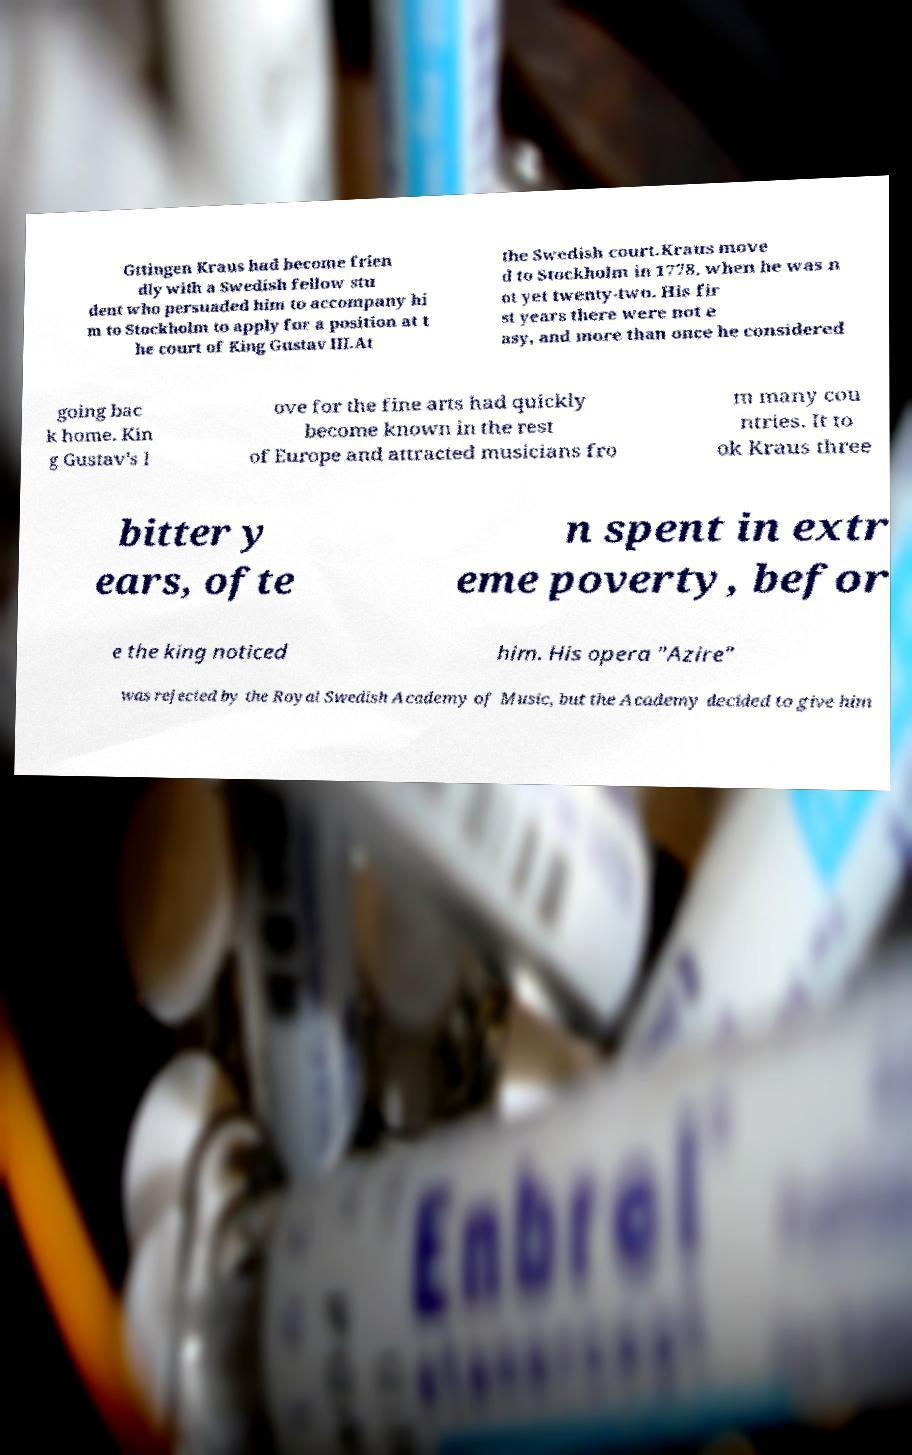There's text embedded in this image that I need extracted. Can you transcribe it verbatim? Gttingen Kraus had become frien dly with a Swedish fellow stu dent who persuaded him to accompany hi m to Stockholm to apply for a position at t he court of King Gustav III.At the Swedish court.Kraus move d to Stockholm in 1778, when he was n ot yet twenty-two. His fir st years there were not e asy, and more than once he considered going bac k home. Kin g Gustav's l ove for the fine arts had quickly become known in the rest of Europe and attracted musicians fro m many cou ntries. It to ok Kraus three bitter y ears, ofte n spent in extr eme poverty, befor e the king noticed him. His opera "Azire" was rejected by the Royal Swedish Academy of Music, but the Academy decided to give him 